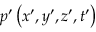<formula> <loc_0><loc_0><loc_500><loc_500>p ^ { \prime } \left ( x ^ { \prime } , y ^ { \prime } , z ^ { \prime } , t ^ { \prime } \right )</formula> 